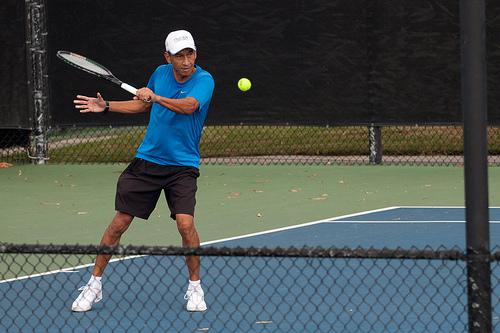Question: who is in the picture?
Choices:
A. A baseball player.
B. A soccer player.
C. A tennis player.
D. A football player.
Answer with the letter. Answer: C Question: how is the man dressed?
Choices:
A. In a robe.
B. In a collared shirt.
C. In a button down and jeans.
D. In shorts and a t shirt.
Answer with the letter. Answer: D Question: what color are his pants?
Choices:
A. White.
B. Blue.
C. Black.
D. Brown.
Answer with the letter. Answer: C Question: what sport is being played?
Choices:
A. Baseball.
B. Soccer.
C. Tennis.
D. Cricket.
Answer with the letter. Answer: C Question: where is he?
Choices:
A. A soccer court.
B. A football court.
C. A baseball court.
D. A tennis court.
Answer with the letter. Answer: D Question: when was the photo taken?
Choices:
A. In the afternoon.
B. Daylight.
C. At night.
D. At sunset.
Answer with the letter. Answer: B 